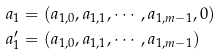<formula> <loc_0><loc_0><loc_500><loc_500>a _ { 1 } & = ( a _ { 1 , 0 } , a _ { 1 , 1 } , \cdots , a _ { 1 , m - 1 } , 0 ) \\ a ^ { \prime } _ { 1 } & = ( a _ { 1 , 0 } , a _ { 1 , 1 } , \cdots , a _ { 1 , m - 1 } )</formula> 